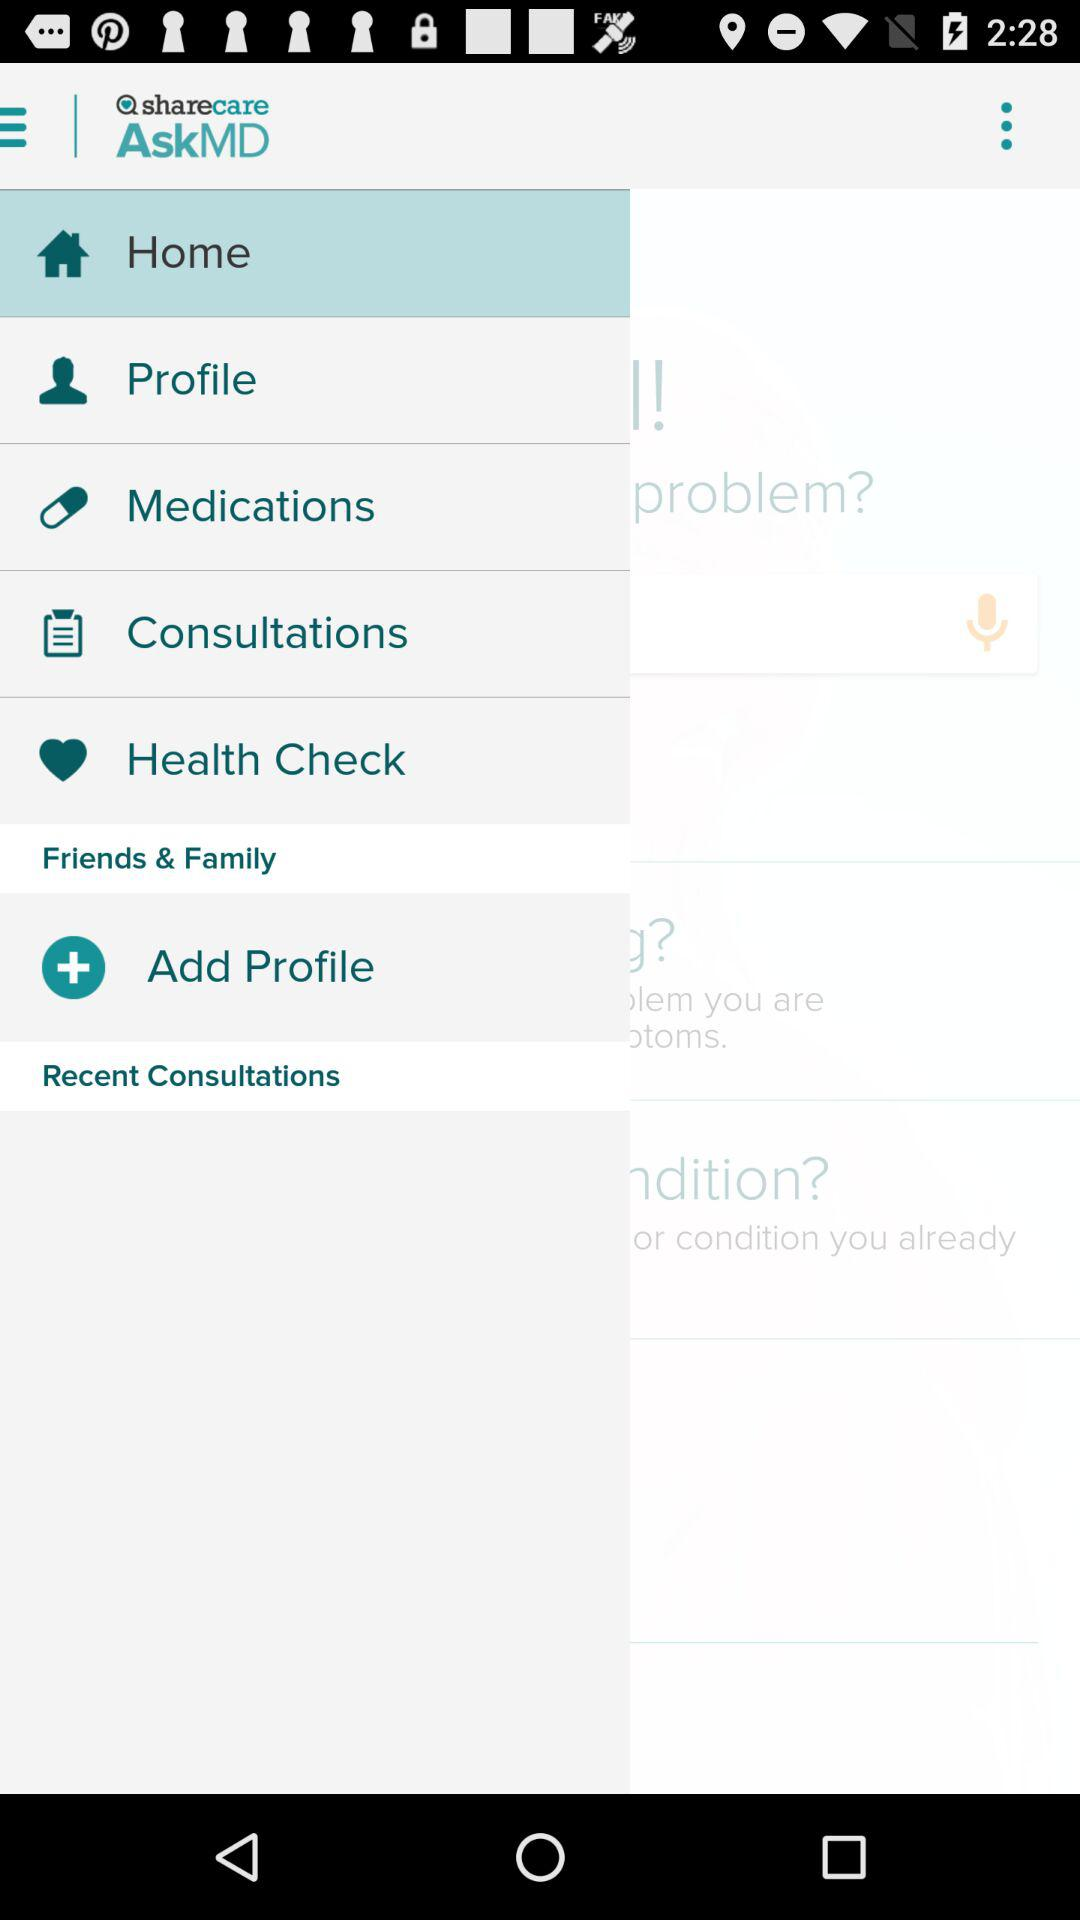What is the application name? The application name is "sharecare AskMD". 